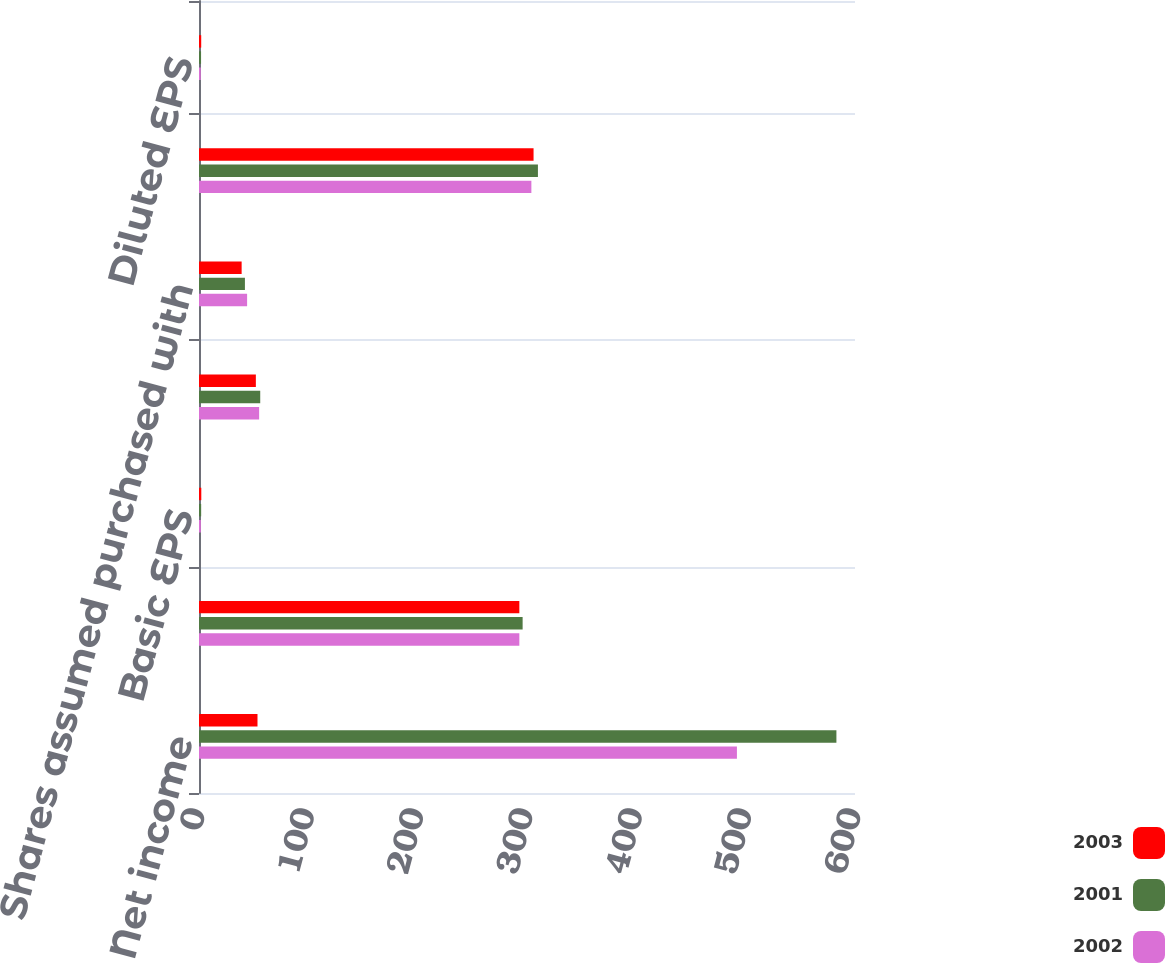Convert chart. <chart><loc_0><loc_0><loc_500><loc_500><stacked_bar_chart><ecel><fcel>Net income<fcel>Weighted-average common shares<fcel>Basic EPS<fcel>Shares assumed issued on<fcel>Shares assumed purchased with<fcel>Shares applicable to diluted<fcel>Diluted EPS<nl><fcel>2003<fcel>53.5<fcel>293<fcel>2.1<fcel>52<fcel>39<fcel>306<fcel>2.02<nl><fcel>2001<fcel>583<fcel>296<fcel>1.97<fcel>56<fcel>42<fcel>310<fcel>1.88<nl><fcel>2002<fcel>492<fcel>293<fcel>1.68<fcel>55<fcel>44<fcel>304<fcel>1.62<nl></chart> 